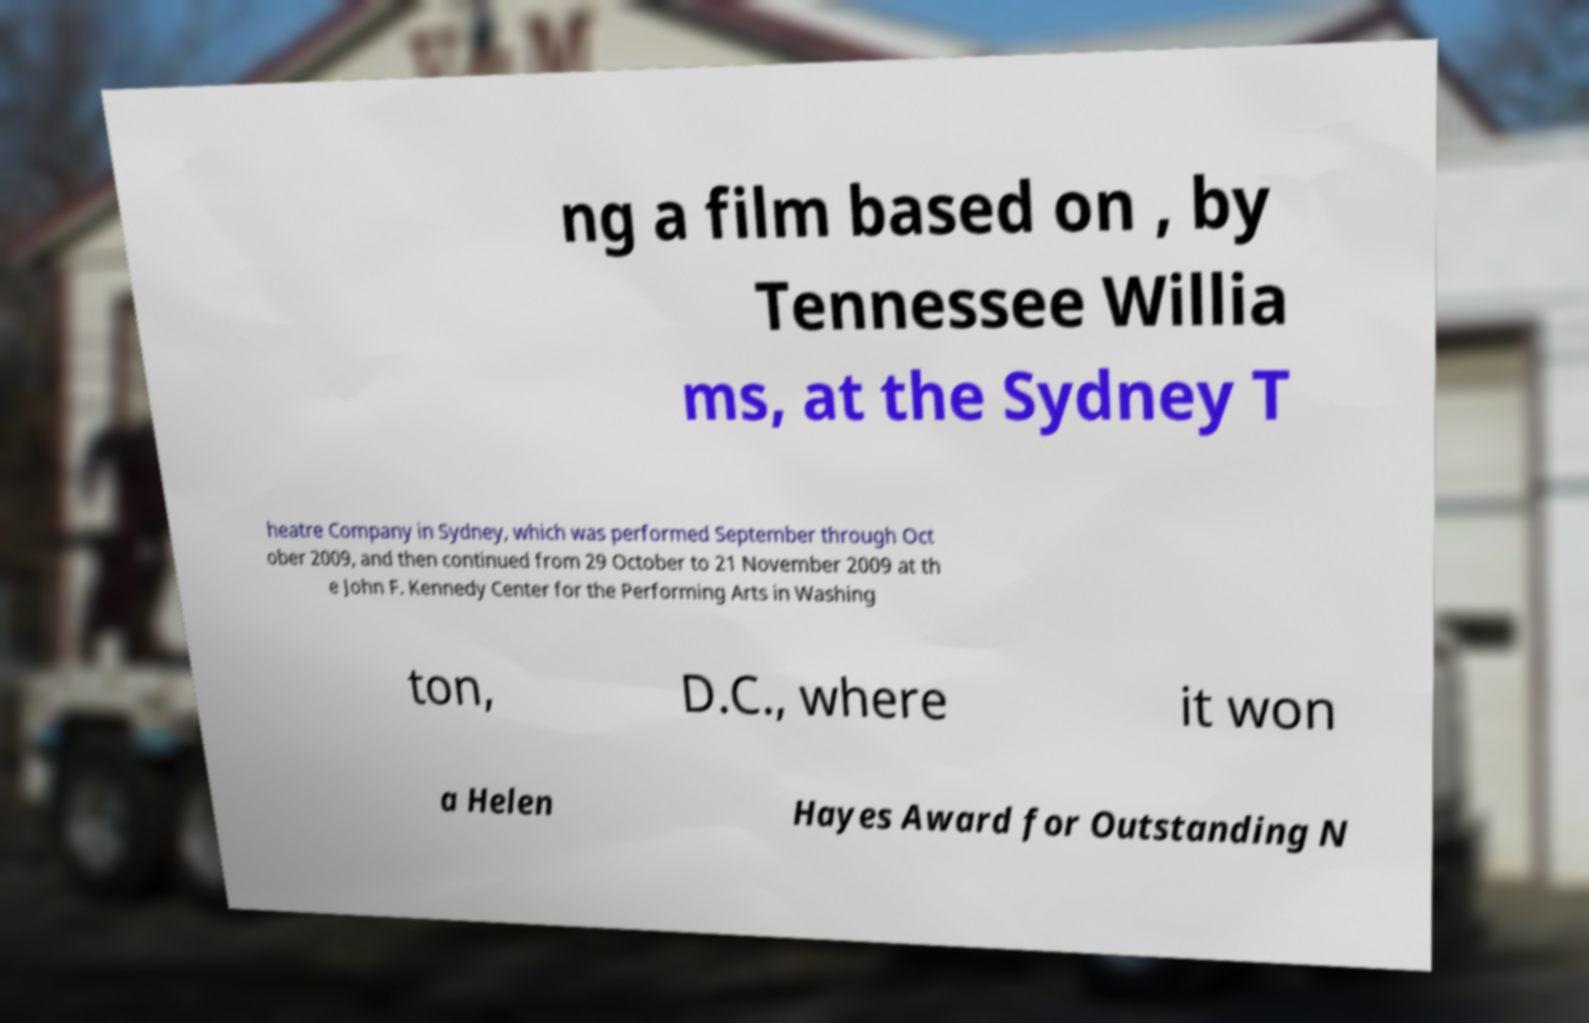What messages or text are displayed in this image? I need them in a readable, typed format. ng a film based on , by Tennessee Willia ms, at the Sydney T heatre Company in Sydney, which was performed September through Oct ober 2009, and then continued from 29 October to 21 November 2009 at th e John F. Kennedy Center for the Performing Arts in Washing ton, D.C., where it won a Helen Hayes Award for Outstanding N 